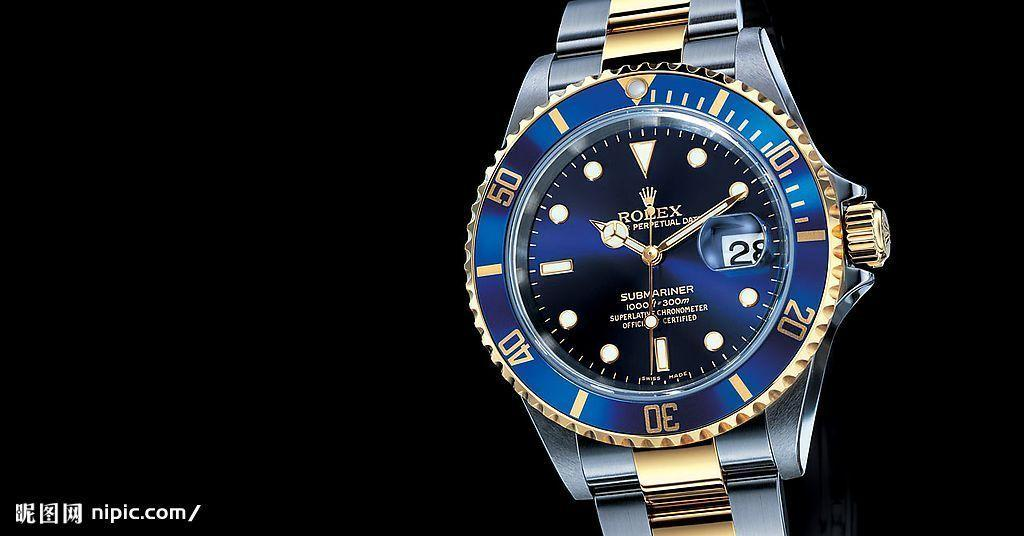<image>
Relay a brief, clear account of the picture shown. A blue Rolex watch has the number 28 on it. 